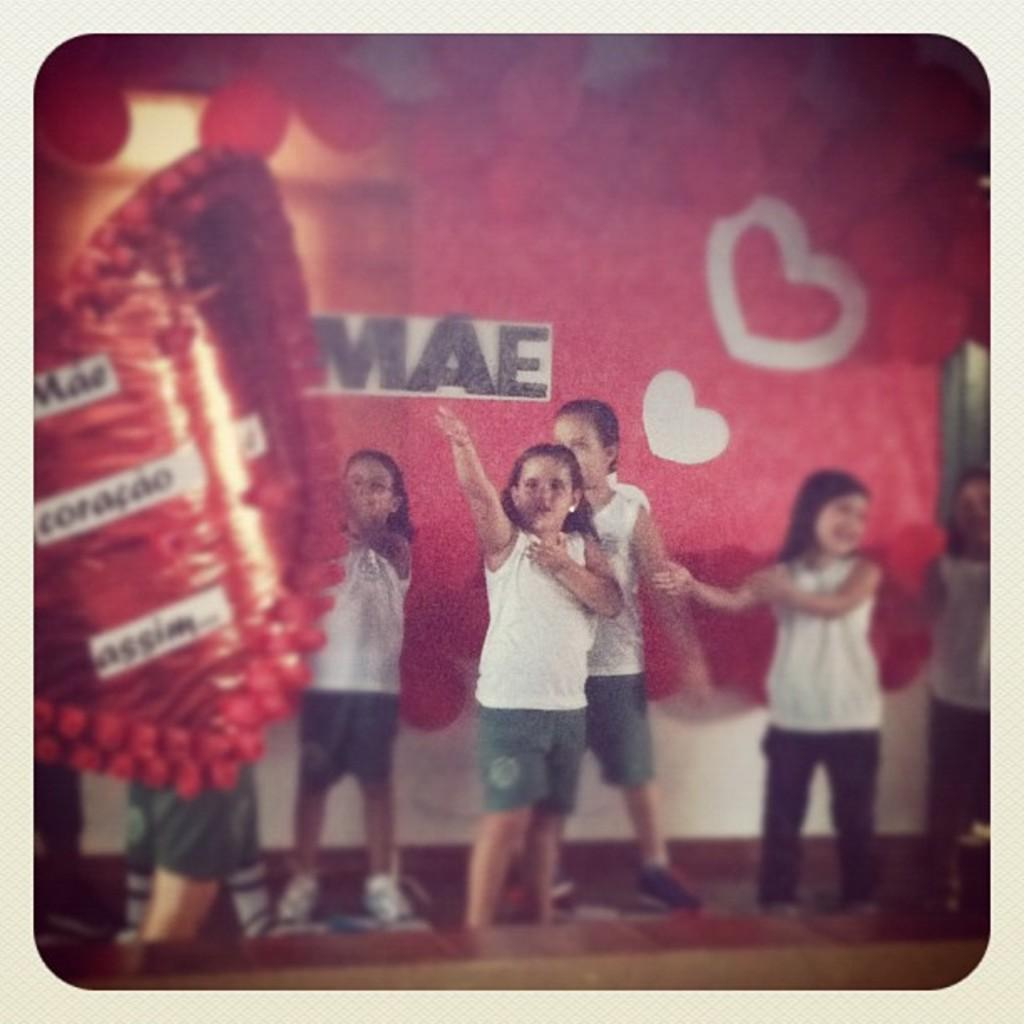What is the main subject of the image? The main subject of the image is a group of children. What are the children doing in the image? The children appear to be standing, and they might be dancing. What additional decorations are present in the image? There is a banner and balloons in the image. What color are the balloons? The balloons are red in color. What type of list can be seen on the children's faces in the image? There is no list present on the children's faces in the image. What sign is the group of children holding in the image? There is no sign visible in the image; only a banner and balloons are present. 